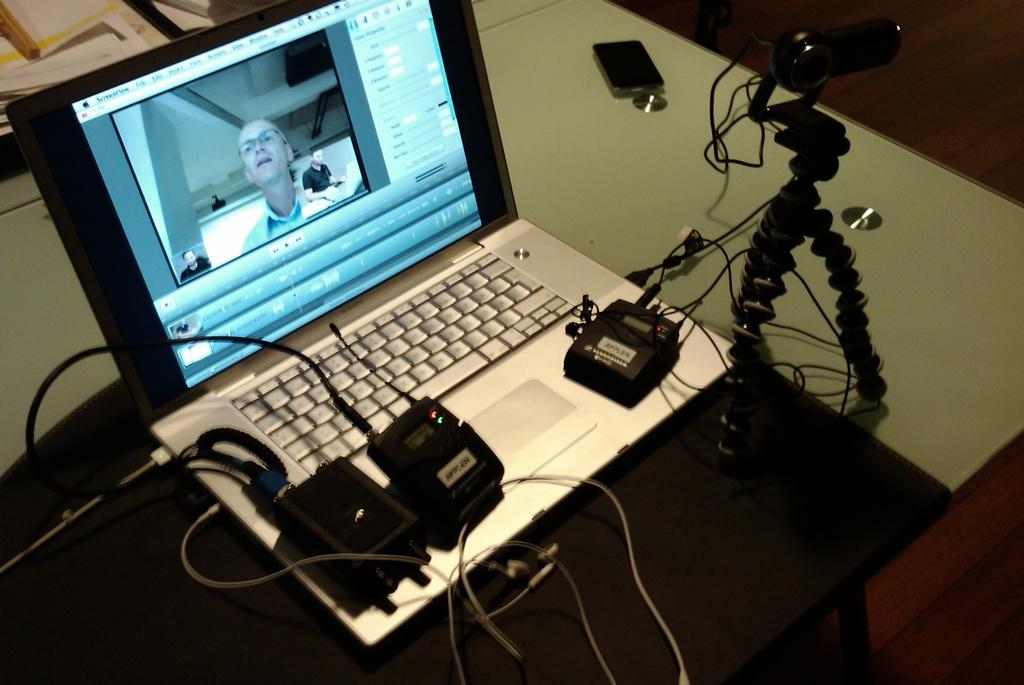What electronic device is visible in the image? There is a laptop in the image. What other objects can be seen in the image? Electrical boxes are visible in the image. How are the electrical boxes connected to each other? The electrical boxes are connected with wires. Where are the laptop and electrical boxes placed? They are placed on a table. How does the laptop provide comfort to the electrical boxes in the image? The laptop does not provide comfort to the electrical boxes in the image; they are separate objects with different functions. 